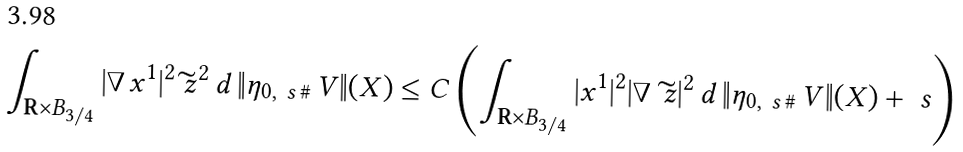Convert formula to latex. <formula><loc_0><loc_0><loc_500><loc_500>\int _ { { \mathbf R } \times B _ { 3 / 4 } } | \nabla \, x ^ { 1 } | ^ { 2 } \widetilde { \ z } ^ { 2 } \, d \, \| \eta _ { 0 , \ s \, \# } \, V \| ( X ) \leq C \left ( \int _ { { \mathbf R } \times B _ { 3 / 4 } } | x ^ { 1 } | ^ { 2 } | \nabla \, \widetilde { \ z } | ^ { 2 } \, d \, \| \eta _ { 0 , \ s \, \# } \, V \| ( X ) + \ s \right )</formula> 